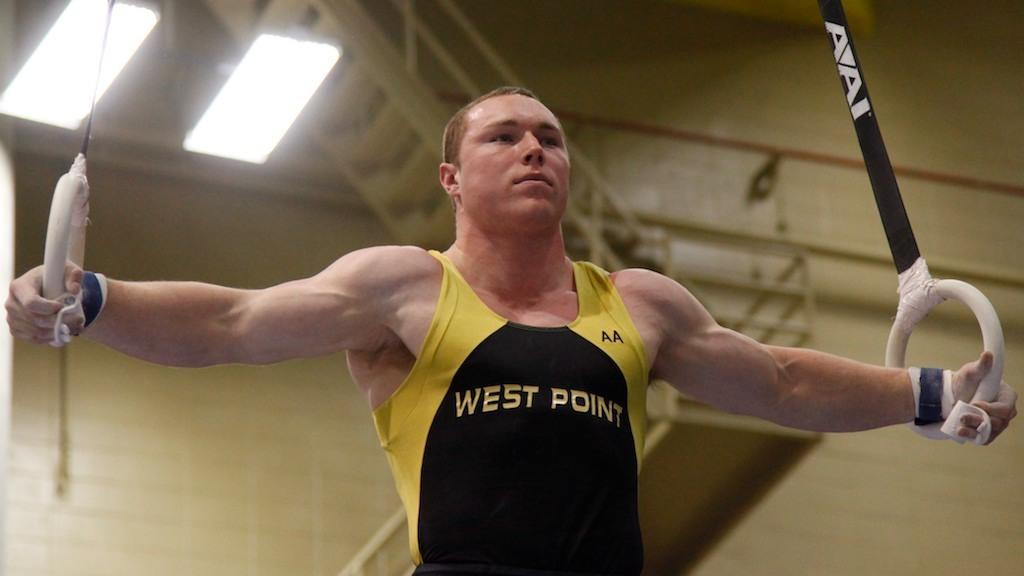<image>
Offer a succinct explanation of the picture presented. A gymnast in a West Point uniform in iron cross formation on the rings. 